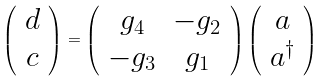<formula> <loc_0><loc_0><loc_500><loc_500>\left ( \begin{array} { c } d \\ c \\ \end{array} \right ) = \left ( \begin{array} { c c } g _ { 4 } & - g _ { 2 } \\ - g _ { 3 } & g _ { 1 } \\ \end{array} \right ) \left ( \begin{array} { c } a \\ a ^ { \dag } \\ \end{array} \right )</formula> 